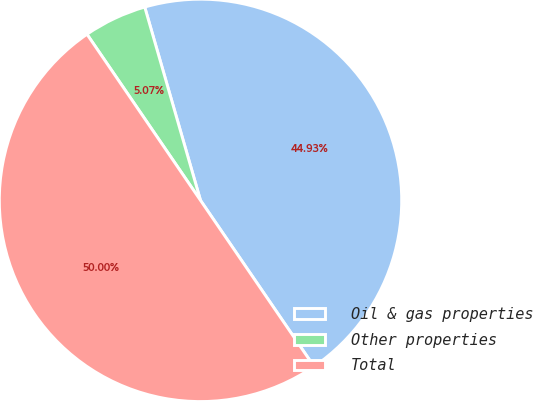<chart> <loc_0><loc_0><loc_500><loc_500><pie_chart><fcel>Oil & gas properties<fcel>Other properties<fcel>Total<nl><fcel>44.93%<fcel>5.07%<fcel>50.0%<nl></chart> 